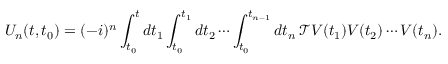Convert formula to latex. <formula><loc_0><loc_0><loc_500><loc_500>U _ { n } ( t , t _ { 0 } ) = ( - i ) ^ { n } \int _ { t _ { 0 } } ^ { t } d t _ { 1 } \int _ { t _ { 0 } } ^ { t _ { 1 } } d t _ { 2 } \cdots \int _ { t _ { 0 } } ^ { t _ { n - 1 } } d t _ { n } \, { \mathcal { T } } V ( t _ { 1 } ) V ( t _ { 2 } ) \cdots V ( t _ { n } ) .</formula> 